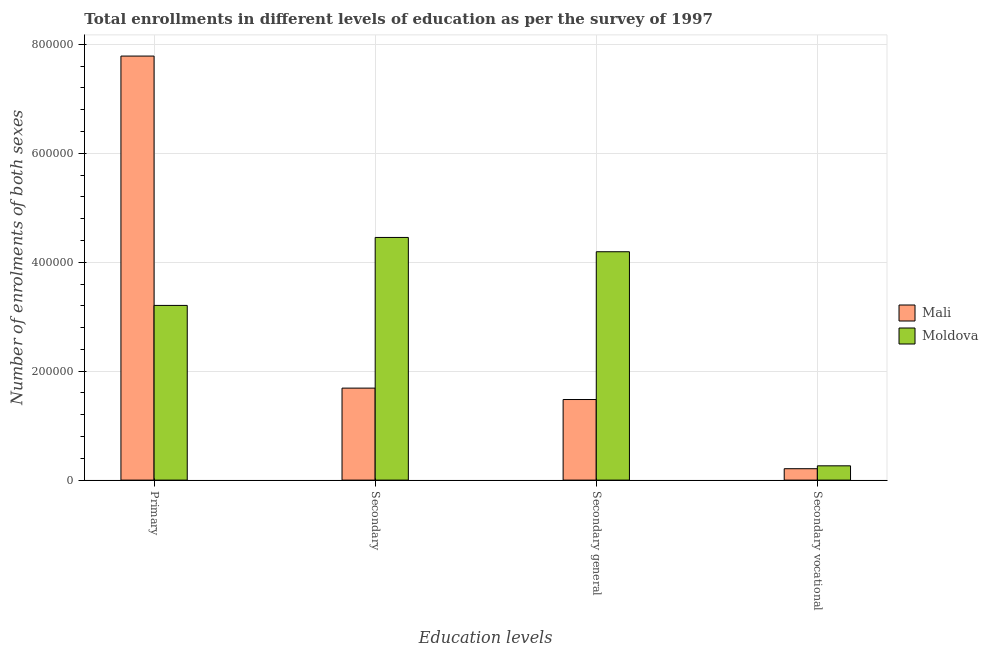How many groups of bars are there?
Your response must be concise. 4. Are the number of bars per tick equal to the number of legend labels?
Provide a succinct answer. Yes. Are the number of bars on each tick of the X-axis equal?
Provide a short and direct response. Yes. How many bars are there on the 4th tick from the right?
Keep it short and to the point. 2. What is the label of the 2nd group of bars from the left?
Your answer should be very brief. Secondary. What is the number of enrolments in secondary vocational education in Mali?
Your answer should be compact. 2.09e+04. Across all countries, what is the maximum number of enrolments in primary education?
Offer a terse response. 7.78e+05. Across all countries, what is the minimum number of enrolments in secondary education?
Offer a very short reply. 1.69e+05. In which country was the number of enrolments in secondary vocational education maximum?
Provide a short and direct response. Moldova. In which country was the number of enrolments in secondary vocational education minimum?
Your answer should be compact. Mali. What is the total number of enrolments in secondary education in the graph?
Make the answer very short. 6.14e+05. What is the difference between the number of enrolments in primary education in Moldova and that in Mali?
Keep it short and to the point. -4.58e+05. What is the difference between the number of enrolments in primary education in Mali and the number of enrolments in secondary vocational education in Moldova?
Your response must be concise. 7.52e+05. What is the average number of enrolments in secondary education per country?
Keep it short and to the point. 3.07e+05. What is the difference between the number of enrolments in secondary education and number of enrolments in primary education in Mali?
Provide a short and direct response. -6.10e+05. In how many countries, is the number of enrolments in secondary general education greater than 560000 ?
Offer a very short reply. 0. What is the ratio of the number of enrolments in secondary vocational education in Moldova to that in Mali?
Provide a succinct answer. 1.25. Is the difference between the number of enrolments in secondary education in Moldova and Mali greater than the difference between the number of enrolments in secondary vocational education in Moldova and Mali?
Offer a very short reply. Yes. What is the difference between the highest and the second highest number of enrolments in primary education?
Make the answer very short. 4.58e+05. What is the difference between the highest and the lowest number of enrolments in primary education?
Provide a succinct answer. 4.58e+05. In how many countries, is the number of enrolments in secondary education greater than the average number of enrolments in secondary education taken over all countries?
Offer a terse response. 1. Is it the case that in every country, the sum of the number of enrolments in secondary education and number of enrolments in secondary vocational education is greater than the sum of number of enrolments in primary education and number of enrolments in secondary general education?
Your answer should be very brief. Yes. What does the 2nd bar from the left in Secondary general represents?
Make the answer very short. Moldova. What does the 1st bar from the right in Primary represents?
Give a very brief answer. Moldova. How many bars are there?
Your answer should be compact. 8. How many countries are there in the graph?
Ensure brevity in your answer.  2. Are the values on the major ticks of Y-axis written in scientific E-notation?
Offer a terse response. No. Where does the legend appear in the graph?
Give a very brief answer. Center right. What is the title of the graph?
Give a very brief answer. Total enrollments in different levels of education as per the survey of 1997. What is the label or title of the X-axis?
Provide a short and direct response. Education levels. What is the label or title of the Y-axis?
Offer a very short reply. Number of enrolments of both sexes. What is the Number of enrolments of both sexes of Mali in Primary?
Offer a terse response. 7.78e+05. What is the Number of enrolments of both sexes in Moldova in Primary?
Provide a succinct answer. 3.21e+05. What is the Number of enrolments of both sexes in Mali in Secondary?
Your answer should be very brief. 1.69e+05. What is the Number of enrolments of both sexes in Moldova in Secondary?
Your answer should be very brief. 4.46e+05. What is the Number of enrolments of both sexes of Mali in Secondary general?
Provide a short and direct response. 1.48e+05. What is the Number of enrolments of both sexes in Moldova in Secondary general?
Your answer should be very brief. 4.19e+05. What is the Number of enrolments of both sexes of Mali in Secondary vocational?
Give a very brief answer. 2.09e+04. What is the Number of enrolments of both sexes in Moldova in Secondary vocational?
Ensure brevity in your answer.  2.62e+04. Across all Education levels, what is the maximum Number of enrolments of both sexes in Mali?
Your response must be concise. 7.78e+05. Across all Education levels, what is the maximum Number of enrolments of both sexes in Moldova?
Provide a short and direct response. 4.46e+05. Across all Education levels, what is the minimum Number of enrolments of both sexes of Mali?
Give a very brief answer. 2.09e+04. Across all Education levels, what is the minimum Number of enrolments of both sexes in Moldova?
Your answer should be compact. 2.62e+04. What is the total Number of enrolments of both sexes in Mali in the graph?
Offer a terse response. 1.12e+06. What is the total Number of enrolments of both sexes of Moldova in the graph?
Offer a very short reply. 1.21e+06. What is the difference between the Number of enrolments of both sexes of Mali in Primary and that in Secondary?
Provide a succinct answer. 6.10e+05. What is the difference between the Number of enrolments of both sexes in Moldova in Primary and that in Secondary?
Offer a terse response. -1.25e+05. What is the difference between the Number of enrolments of both sexes of Mali in Primary and that in Secondary general?
Your response must be concise. 6.30e+05. What is the difference between the Number of enrolments of both sexes of Moldova in Primary and that in Secondary general?
Your answer should be compact. -9.85e+04. What is the difference between the Number of enrolments of both sexes of Mali in Primary and that in Secondary vocational?
Give a very brief answer. 7.58e+05. What is the difference between the Number of enrolments of both sexes of Moldova in Primary and that in Secondary vocational?
Provide a succinct answer. 2.94e+05. What is the difference between the Number of enrolments of both sexes of Mali in Secondary and that in Secondary general?
Give a very brief answer. 2.09e+04. What is the difference between the Number of enrolments of both sexes of Moldova in Secondary and that in Secondary general?
Provide a succinct answer. 2.62e+04. What is the difference between the Number of enrolments of both sexes of Mali in Secondary and that in Secondary vocational?
Ensure brevity in your answer.  1.48e+05. What is the difference between the Number of enrolments of both sexes in Moldova in Secondary and that in Secondary vocational?
Provide a short and direct response. 4.19e+05. What is the difference between the Number of enrolments of both sexes in Mali in Secondary general and that in Secondary vocational?
Provide a short and direct response. 1.27e+05. What is the difference between the Number of enrolments of both sexes of Moldova in Secondary general and that in Secondary vocational?
Offer a very short reply. 3.93e+05. What is the difference between the Number of enrolments of both sexes of Mali in Primary and the Number of enrolments of both sexes of Moldova in Secondary?
Your response must be concise. 3.33e+05. What is the difference between the Number of enrolments of both sexes of Mali in Primary and the Number of enrolments of both sexes of Moldova in Secondary general?
Your answer should be very brief. 3.59e+05. What is the difference between the Number of enrolments of both sexes in Mali in Primary and the Number of enrolments of both sexes in Moldova in Secondary vocational?
Give a very brief answer. 7.52e+05. What is the difference between the Number of enrolments of both sexes in Mali in Secondary and the Number of enrolments of both sexes in Moldova in Secondary general?
Your answer should be compact. -2.50e+05. What is the difference between the Number of enrolments of both sexes in Mali in Secondary and the Number of enrolments of both sexes in Moldova in Secondary vocational?
Give a very brief answer. 1.43e+05. What is the difference between the Number of enrolments of both sexes of Mali in Secondary general and the Number of enrolments of both sexes of Moldova in Secondary vocational?
Your answer should be compact. 1.22e+05. What is the average Number of enrolments of both sexes of Mali per Education levels?
Your answer should be compact. 2.79e+05. What is the average Number of enrolments of both sexes of Moldova per Education levels?
Your answer should be compact. 3.03e+05. What is the difference between the Number of enrolments of both sexes of Mali and Number of enrolments of both sexes of Moldova in Primary?
Your response must be concise. 4.58e+05. What is the difference between the Number of enrolments of both sexes in Mali and Number of enrolments of both sexes in Moldova in Secondary?
Make the answer very short. -2.77e+05. What is the difference between the Number of enrolments of both sexes in Mali and Number of enrolments of both sexes in Moldova in Secondary general?
Make the answer very short. -2.71e+05. What is the difference between the Number of enrolments of both sexes in Mali and Number of enrolments of both sexes in Moldova in Secondary vocational?
Your answer should be compact. -5306. What is the ratio of the Number of enrolments of both sexes of Mali in Primary to that in Secondary?
Give a very brief answer. 4.61. What is the ratio of the Number of enrolments of both sexes in Moldova in Primary to that in Secondary?
Offer a terse response. 0.72. What is the ratio of the Number of enrolments of both sexes of Mali in Primary to that in Secondary general?
Offer a very short reply. 5.26. What is the ratio of the Number of enrolments of both sexes in Moldova in Primary to that in Secondary general?
Ensure brevity in your answer.  0.77. What is the ratio of the Number of enrolments of both sexes in Mali in Primary to that in Secondary vocational?
Ensure brevity in your answer.  37.18. What is the ratio of the Number of enrolments of both sexes of Moldova in Primary to that in Secondary vocational?
Your response must be concise. 12.22. What is the ratio of the Number of enrolments of both sexes in Mali in Secondary to that in Secondary general?
Ensure brevity in your answer.  1.14. What is the ratio of the Number of enrolments of both sexes of Moldova in Secondary to that in Secondary general?
Offer a terse response. 1.06. What is the ratio of the Number of enrolments of both sexes of Mali in Secondary to that in Secondary vocational?
Offer a very short reply. 8.07. What is the ratio of the Number of enrolments of both sexes in Moldova in Secondary to that in Secondary vocational?
Keep it short and to the point. 16.97. What is the ratio of the Number of enrolments of both sexes of Mali in Secondary general to that in Secondary vocational?
Provide a succinct answer. 7.07. What is the ratio of the Number of enrolments of both sexes in Moldova in Secondary general to that in Secondary vocational?
Ensure brevity in your answer.  15.97. What is the difference between the highest and the second highest Number of enrolments of both sexes of Mali?
Your answer should be compact. 6.10e+05. What is the difference between the highest and the second highest Number of enrolments of both sexes of Moldova?
Provide a succinct answer. 2.62e+04. What is the difference between the highest and the lowest Number of enrolments of both sexes of Mali?
Offer a terse response. 7.58e+05. What is the difference between the highest and the lowest Number of enrolments of both sexes in Moldova?
Your answer should be compact. 4.19e+05. 